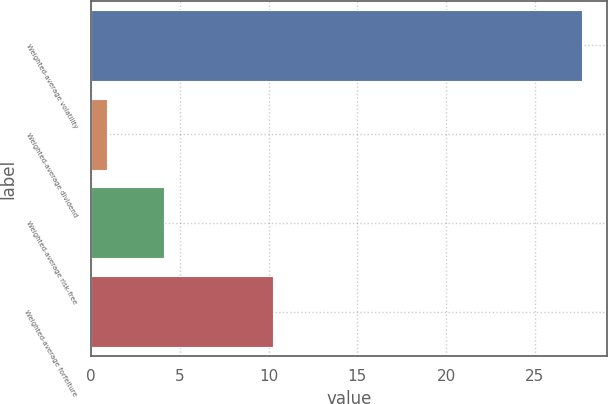<chart> <loc_0><loc_0><loc_500><loc_500><bar_chart><fcel>Weighted-average volatility<fcel>Weighted-average dividend<fcel>Weighted-average risk-free<fcel>Weighted-average forfeiture<nl><fcel>27.66<fcel>0.88<fcel>4.08<fcel>10.22<nl></chart> 